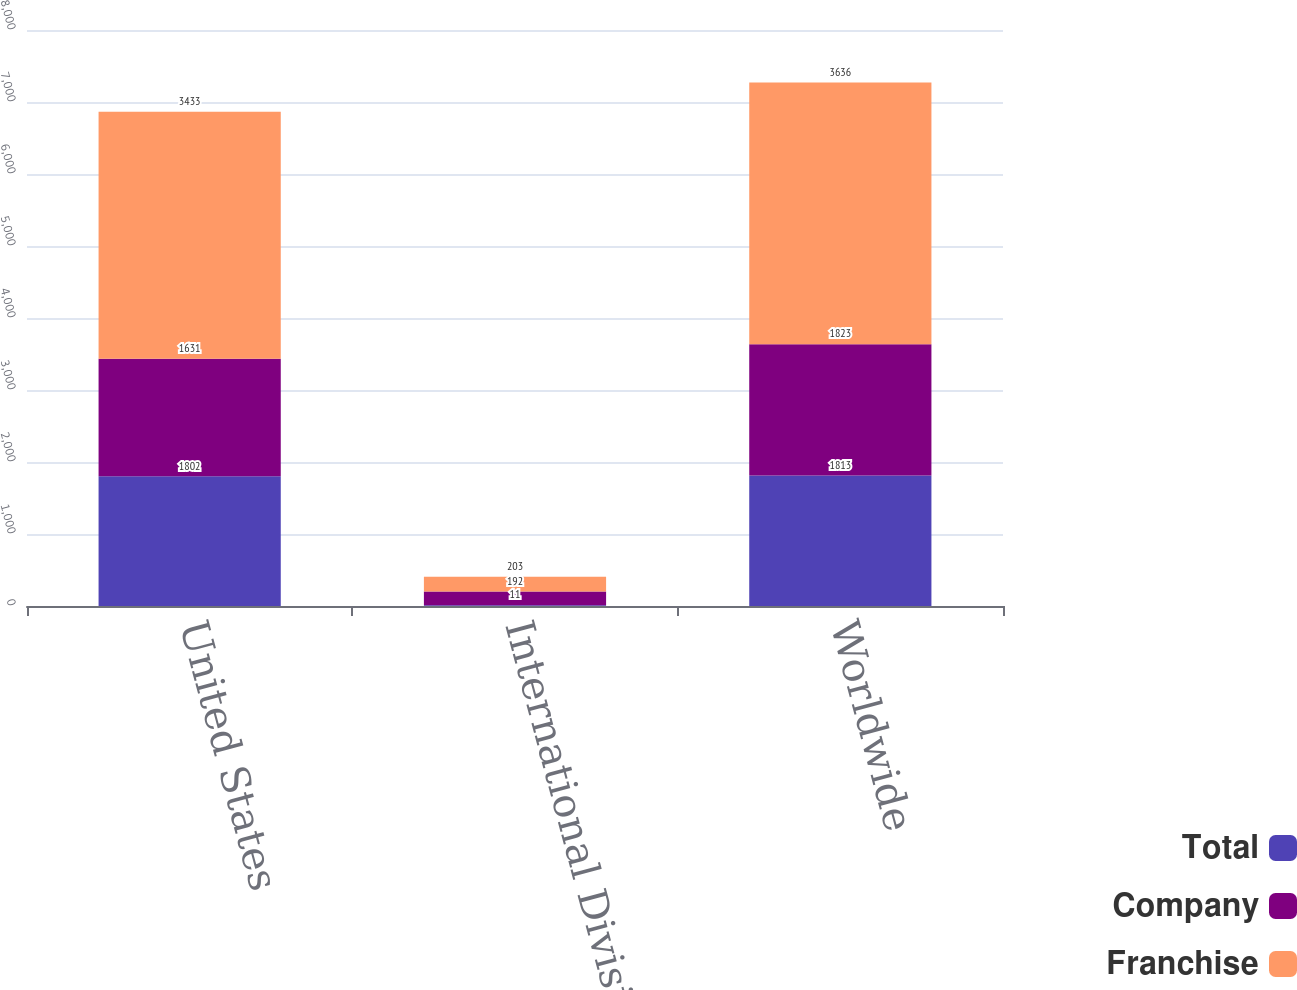<chart> <loc_0><loc_0><loc_500><loc_500><stacked_bar_chart><ecel><fcel>United States<fcel>International Division<fcel>Worldwide<nl><fcel>Total<fcel>1802<fcel>11<fcel>1813<nl><fcel>Company<fcel>1631<fcel>192<fcel>1823<nl><fcel>Franchise<fcel>3433<fcel>203<fcel>3636<nl></chart> 